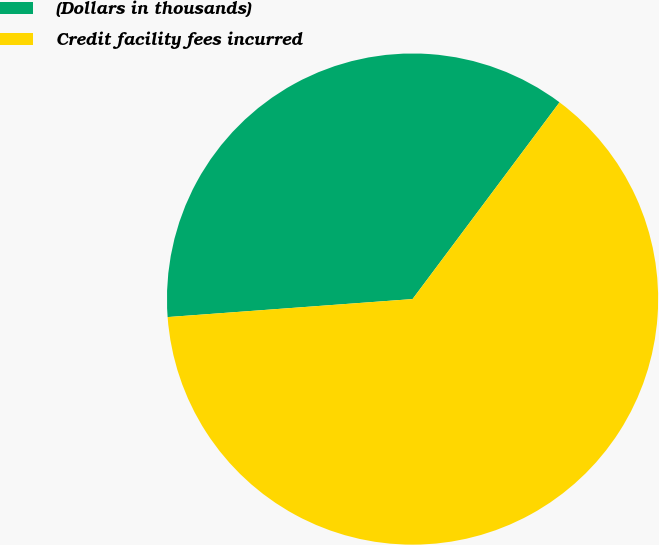Convert chart. <chart><loc_0><loc_0><loc_500><loc_500><pie_chart><fcel>(Dollars in thousands)<fcel>Credit facility fees incurred<nl><fcel>36.38%<fcel>63.62%<nl></chart> 